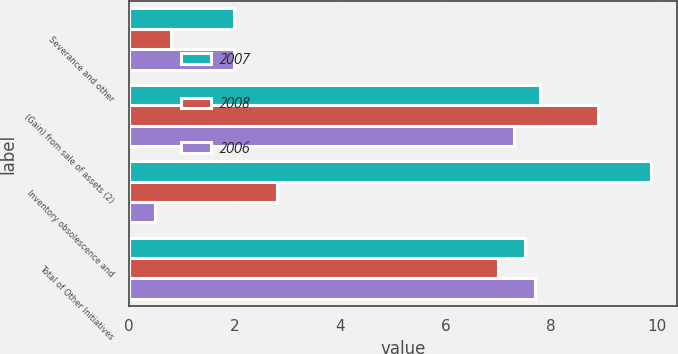Convert chart. <chart><loc_0><loc_0><loc_500><loc_500><stacked_bar_chart><ecel><fcel>Severance and other<fcel>(Gain) from sale of assets (2)<fcel>Inventory obsolescence and<fcel>Total of Other Initiatives<nl><fcel>2007<fcel>2<fcel>7.8<fcel>9.9<fcel>7.5<nl><fcel>2008<fcel>0.8<fcel>8.9<fcel>2.8<fcel>7<nl><fcel>2006<fcel>2<fcel>7.3<fcel>0.5<fcel>7.7<nl></chart> 